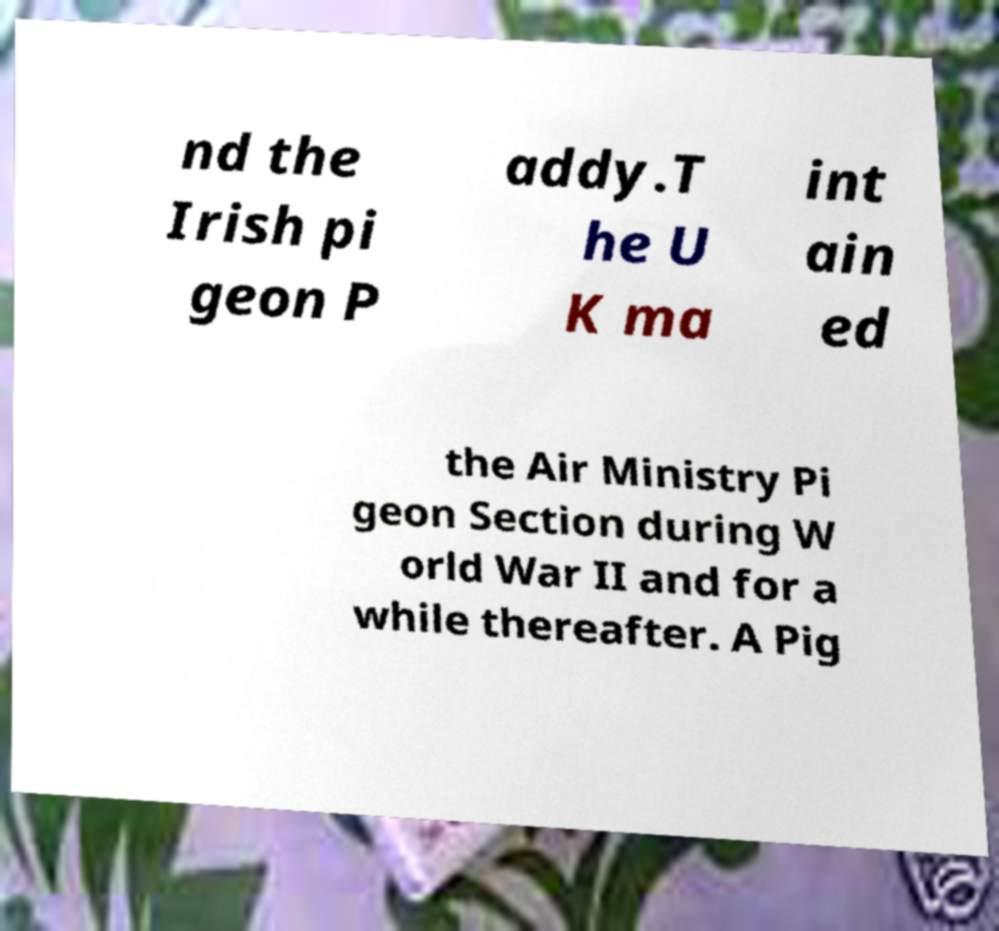What messages or text are displayed in this image? I need them in a readable, typed format. nd the Irish pi geon P addy.T he U K ma int ain ed the Air Ministry Pi geon Section during W orld War II and for a while thereafter. A Pig 